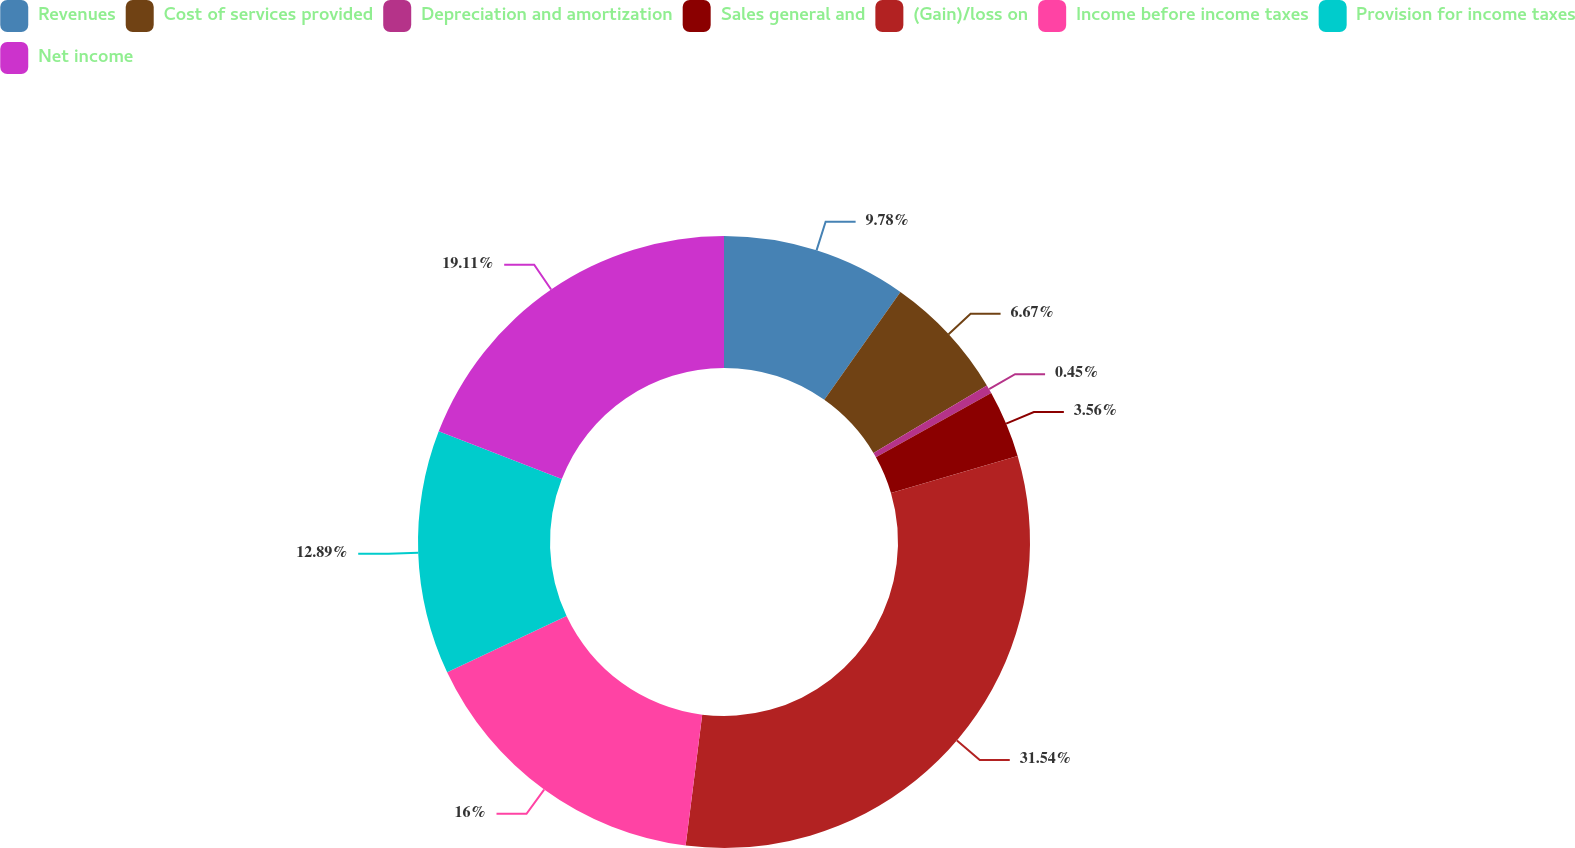Convert chart. <chart><loc_0><loc_0><loc_500><loc_500><pie_chart><fcel>Revenues<fcel>Cost of services provided<fcel>Depreciation and amortization<fcel>Sales general and<fcel>(Gain)/loss on<fcel>Income before income taxes<fcel>Provision for income taxes<fcel>Net income<nl><fcel>9.78%<fcel>6.67%<fcel>0.45%<fcel>3.56%<fcel>31.54%<fcel>16.0%<fcel>12.89%<fcel>19.11%<nl></chart> 